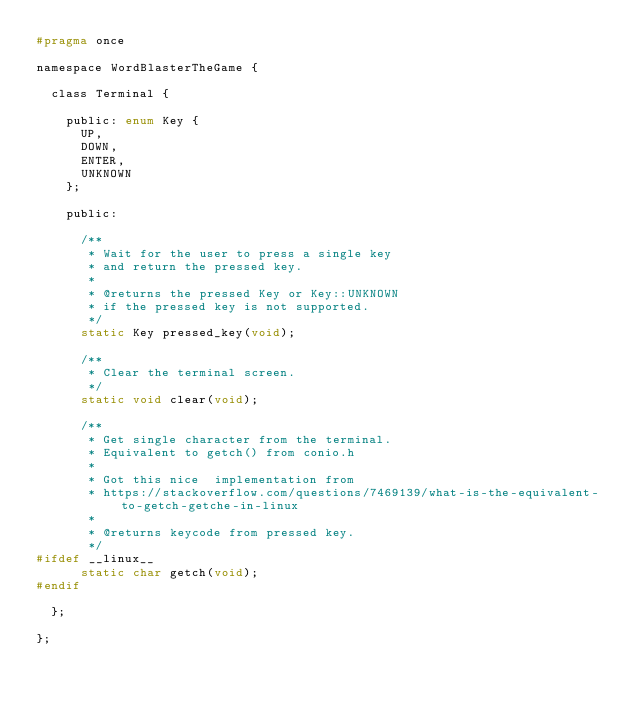Convert code to text. <code><loc_0><loc_0><loc_500><loc_500><_C_>#pragma once

namespace WordBlasterTheGame {

  class Terminal {

    public: enum Key {
      UP,
      DOWN,
      ENTER,
      UNKNOWN
    };

    public:

      /**
       * Wait for the user to press a single key
       * and return the pressed key.
       * 
       * @returns the pressed Key or Key::UNKNOWN
       * if the pressed key is not supported.
       */
      static Key pressed_key(void);

      /**
       * Clear the terminal screen.
       */
      static void clear(void);

      /**
       * Get single character from the terminal.
       * Equivalent to getch() from conio.h
       * 
       * Got this nice  implementation from
       * https://stackoverflow.com/questions/7469139/what-is-the-equivalent-to-getch-getche-in-linux
       *
       * @returns keycode from pressed key.
       */
#ifdef __linux__
      static char getch(void);
#endif

  };

};
</code> 